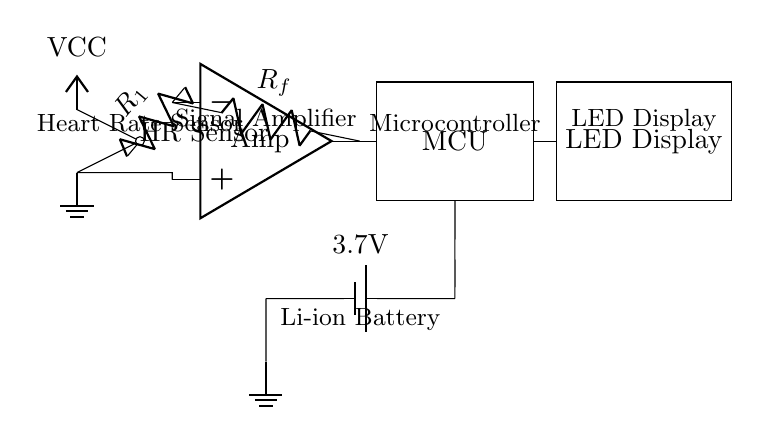What is the main function of the heart rate sensor? The heart rate sensor's primary function is to detect the user's heart rate by measuring the blood flow or pulse. This is indicated by the label "HR Sensor" in the diagram.
Answer: Heart rate detection What type of amplifier is used in this circuit? The circuit uses an operational amplifier (op amp), which is denoted by the label "Amp" in the diagram. Operational amplifiers are commonly used for signal amplification in various applications.
Answer: Operational amplifier What is the voltage rating of the battery in this circuit? The battery is rated at 3.7V, as indicated in the description alongside the battery symbol in the circuit diagram, which shows the potential power supply for the circuit.
Answer: 3.7V How does the microcontroller interact with the heart rate sensor? The microcontroller receives the amplified signal from the heart rate sensor through the operational amplifier, allowing it to process the data. This flow is represented by the line connecting the op amp output to the MCU.
Answer: By receiving amplified signals What is the purpose of the LED display in this circuit? The LED display is used to visually represent the heart rate data processed by the microcontroller. This display is linked to the microcontroller as shown by the connection in the circuit diagram.
Answer: Visual representation of heart rate What role does the resistor play in this circuit? The resistor in the circuit, labeled R1, is part of the signal conditioning process, offering stability and setting the gain in the amplifier circuit. It is essential for maintaining the integrity of the signal being amplified.
Answer: Signal conditioning and stability 